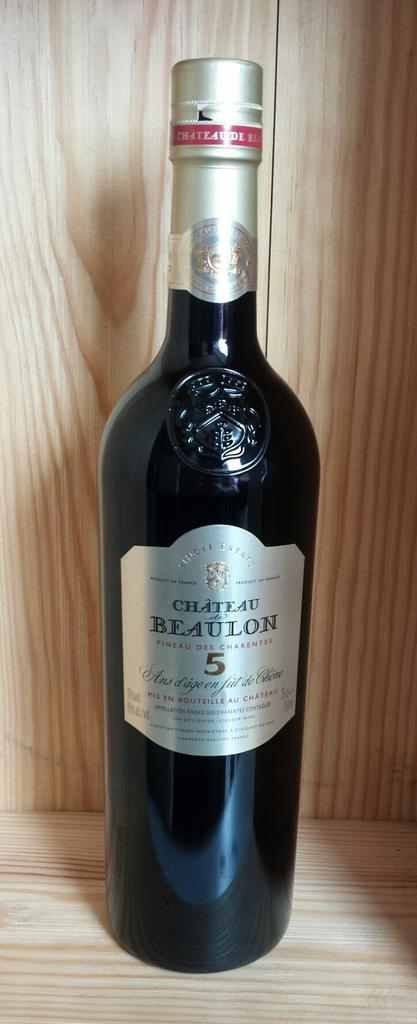<image>
Present a compact description of the photo's key features. A black bottle of Chateau Beaulon is on display on a wooden shelf. 